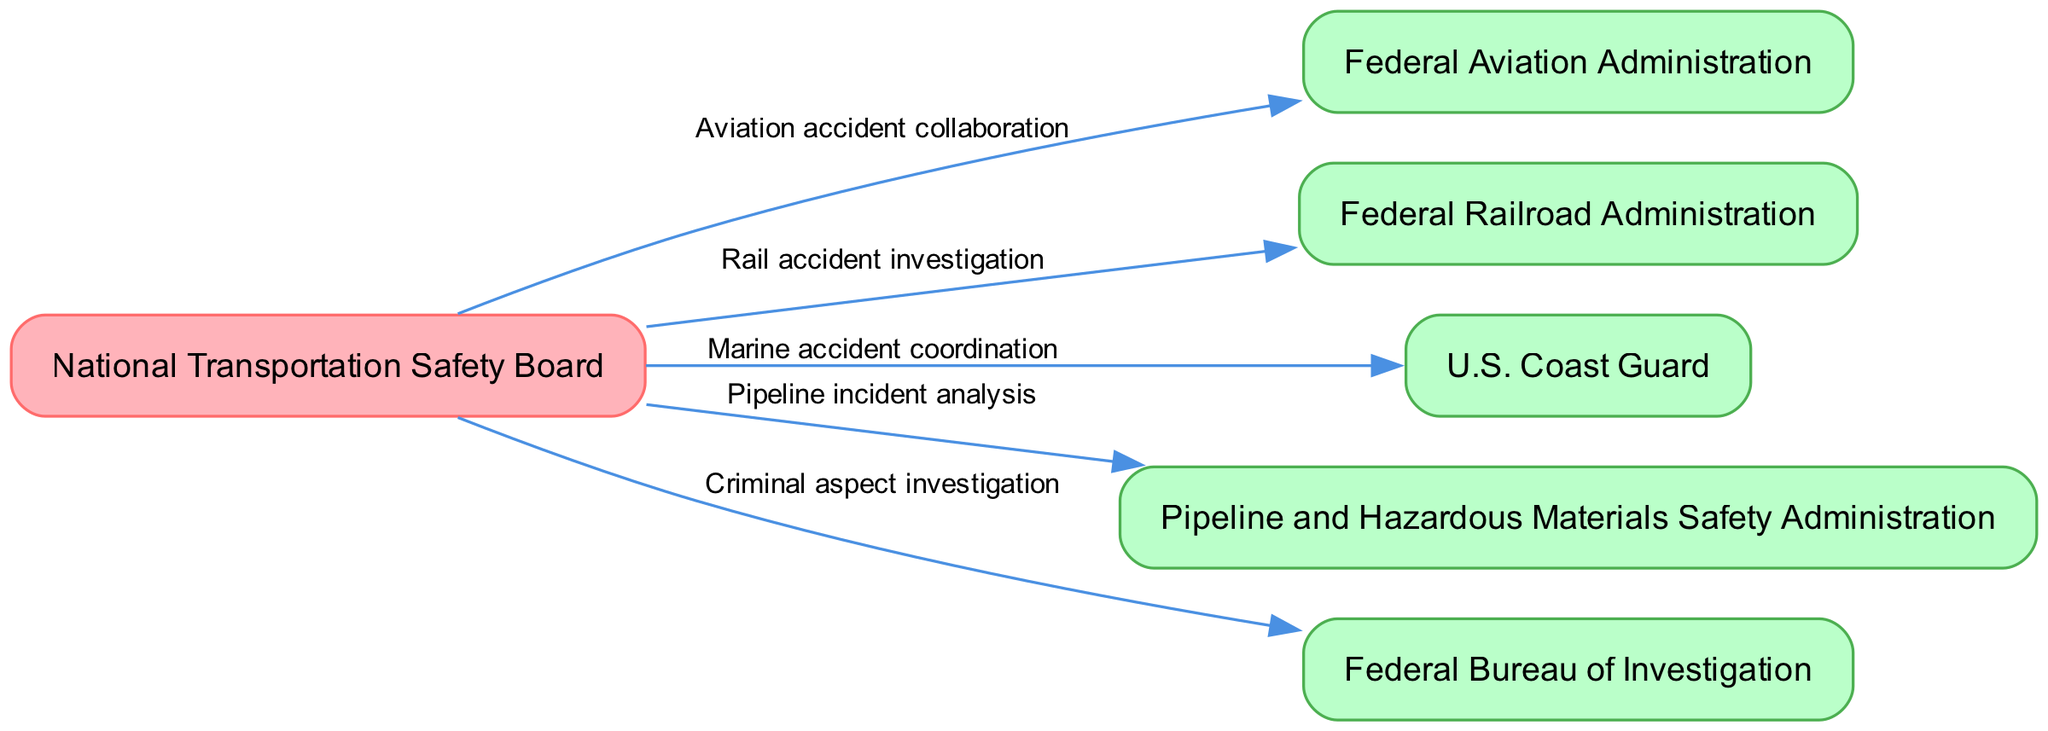What is the total number of nodes in the diagram? The nodes in the diagram are the entities involved in the interagency collaboration network. They include NTSB, FAA, FRA, USCG, PHMSA, and FBI, totaling six nodes.
Answer: 6 Which agency is primarily connected to the Federal Aviation Administration? The edge from NTSB to FAA indicates that the National Transportation Safety Board is primarily connected to the Federal Aviation Administration.
Answer: NTSB What type of investigation involves the FBI in this diagram? The edge from NTSB to FBI is labeled "Criminal aspect investigation," indicating the type of investigation involving the FBI.
Answer: Criminal aspect investigation How many edges are depicted in the collaboration network? The edges represent the various collaboration types between agencies and NTSB. The list shows five connections, indicating there are five edges.
Answer: 5 Which agency does the NTSB coordinate with for marine accidents? The edge labeled "Marine accident coordination" connects NTSB to the U.S. Coast Guard, indicating the agency NTSB coordinates with for marine accidents.
Answer: U.S. Coast Guard What is the relationship between NTSB and PHMSA? The edge between NTSB and PHMSA indicates a direct relationship labeled "Pipeline incident analysis," defining the nature of their collaboration.
Answer: Pipeline incident analysis Which node has the most connections in the diagram? NTSB is the central node that connects to all other agencies, making it the node with the most connections in the diagram.
Answer: NTSB What is the primary function of the U.S. Coast Guard with respect to NTSB? The collaboration indicated by the edge labeled "Marine accident coordination" shows the primary function of the U.S. Coast Guard in relation to NTSB.
Answer: Marine accident coordination 